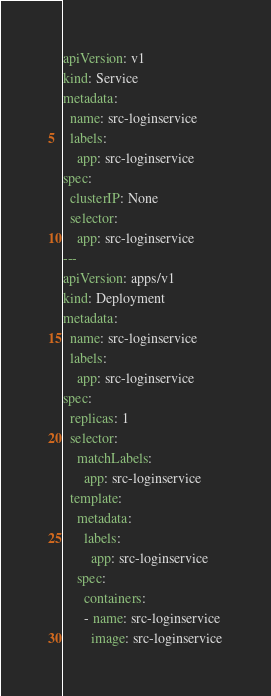<code> <loc_0><loc_0><loc_500><loc_500><_YAML_>apiVersion: v1
kind: Service
metadata:
  name: src-loginservice
  labels:
    app: src-loginservice
spec:
  clusterIP: None
  selector:
    app: src-loginservice
---
apiVersion: apps/v1
kind: Deployment
metadata:
  name: src-loginservice
  labels:
    app: src-loginservice
spec:
  replicas: 1
  selector:
    matchLabels:
      app: src-loginservice
  template:
    metadata:
      labels:
        app: src-loginservice
    spec:
      containers:
      - name: src-loginservice
        image: src-loginservice
</code> 